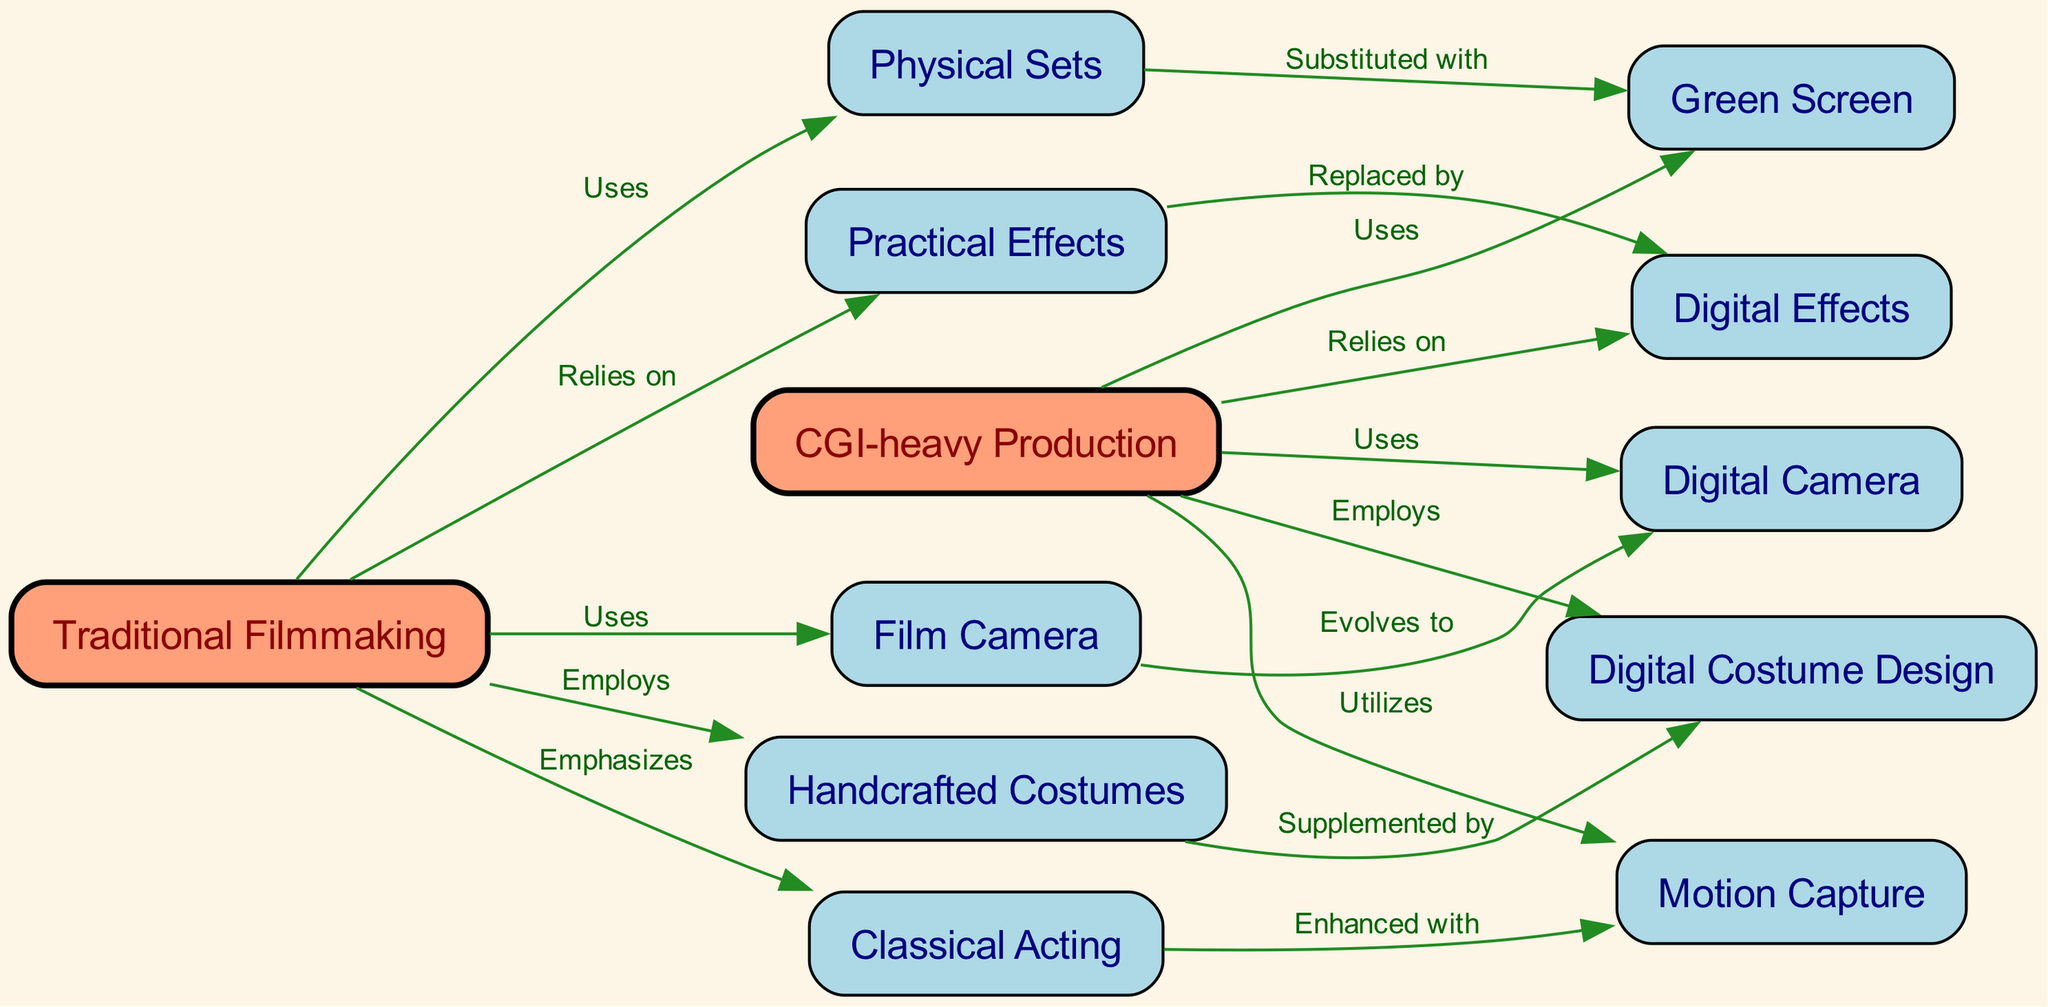What are the two main categories in this diagram? The diagram has two primary nodes that represent the main categories: "Traditional Filmmaking" and "CGI-heavy Production." These nodes are prominently positioned and act as the core classifications of the filmmaking techniques compared.
Answer: Traditional Filmmaking, CGI-heavy Production How many nodes are there in total? By counting each individual entity listed in the nodes section of the diagram, we find there are 12 distinct nodes, which represent various aspects related to both traditional and CGI filmmaking techniques.
Answer: 12 What does "Traditional Filmmaking" rely on? The directed edge from "Traditional Filmmaking" to "Practical Effects" indicates that traditional filmmaking relies on practical effects. This relationship directly represents the dependency shown in the diagram.
Answer: Practical Effects What is substituted with "Green Screen"? The directed edge from "Physical Sets" to "Green Screen" indicates that in CGI-heavy productions, physical sets are often substituted with green screens, which allow for more digital manipulation during filming.
Answer: Physical Sets What technique is enhanced with "Motion Capture"? The directed edge from "Classical Acting" to "Motion Capture" signifies that classical acting is enhanced with the use of motion capture technology, which allows for the actors' performances to be translated into digital characters.
Answer: Classical Acting Which filmmaking technique uses a film camera? The edge leading from "Traditional Filmmaking" to "Film Camera" shows that traditional filmmaking utilizes a film camera, differentiating it from digital techniques in CGI-heavy processes.
Answer: Film Camera How many relationships are indicated by edges in this diagram? By counting the edges listed, we can observe that there are a total of 15 directed relationships (edges) that connect the nodes, representing various dependencies and associations among different filmmaking methods.
Answer: 15 What does "Digital Effects" replace? The directed edge from "Practical Effects" to "Digital Effects" shows that digital effects replaced practical effects in many modern productions, indicating a shift in technique and technology.
Answer: Practical Effects What is employed in "CGI-heavy Production"? The directed edge indicates that "Digital Costume Design" is employed in CGI-heavy production, showcasing how digital technology is used to create costumes instead of traditional methods.
Answer: Digital Costume Design 